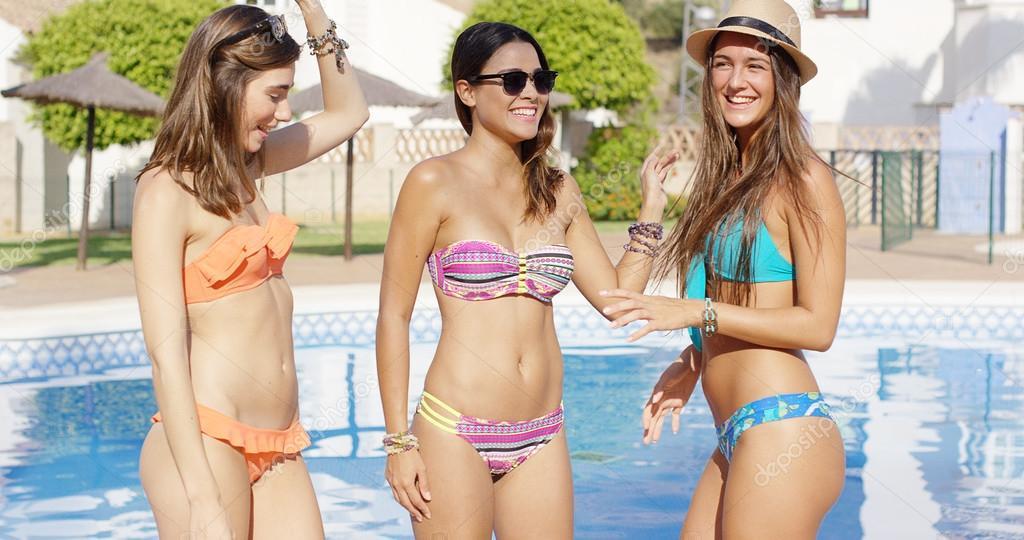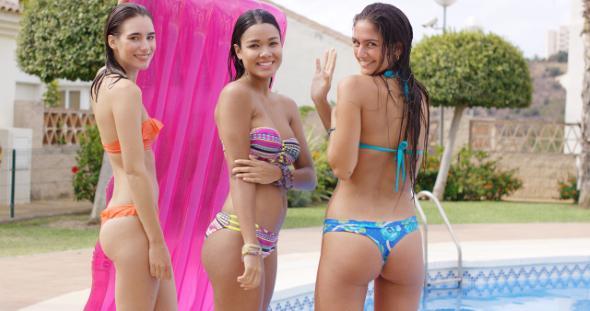The first image is the image on the left, the second image is the image on the right. Assess this claim about the two images: "Three women are standing on the shore in the image on the left.". Correct or not? Answer yes or no. No. 